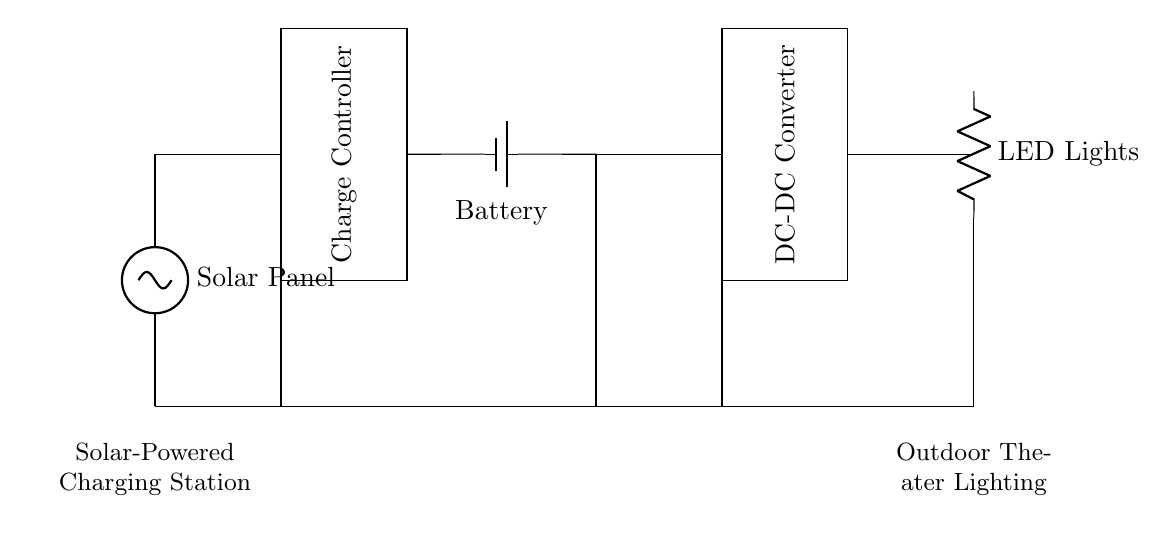What are the main components of the circuit? The circuit includes a solar panel, a charge controller, a battery, a DC-DC converter, and LED lights. Each of these components is essential for converting solar energy into usable electrical power.
Answer: solar panel, charge controller, battery, DC-DC converter, LED lights What is the purpose of the charge controller? The charge controller regulates the voltage and current coming from the solar panel to ensure that the battery is charged appropriately without overcharging, which can damage the battery.
Answer: regulation What does the DC-DC converter do in this circuit? The DC-DC converter transforms one voltage level to another, allowing the stored energy in the battery to be converted to the appropriate voltage needed for the LED lights. This ensures optimal performance of the lights.
Answer: voltage transformation How are the components connected in relation to each other? The components are connected in series. The solar panel feeds into the charge controller, which connects to the battery, followed by the DC-DC converter, and finally delivering power to the LED lights. This series configuration allows for a sequential charging and power distribution process.
Answer: series What type of energy does the solar panel convert? The solar panel converts solar energy from sunlight into electrical energy, which is then used to charge the battery and power the lighting system.
Answer: solar energy Which component is responsible for lighting the outdoor theater? The LED lights, connected at the end of the circuit after the DC-DC converter, are responsible for providing the lighting necessary for outdoor performances.
Answer: LED lights 